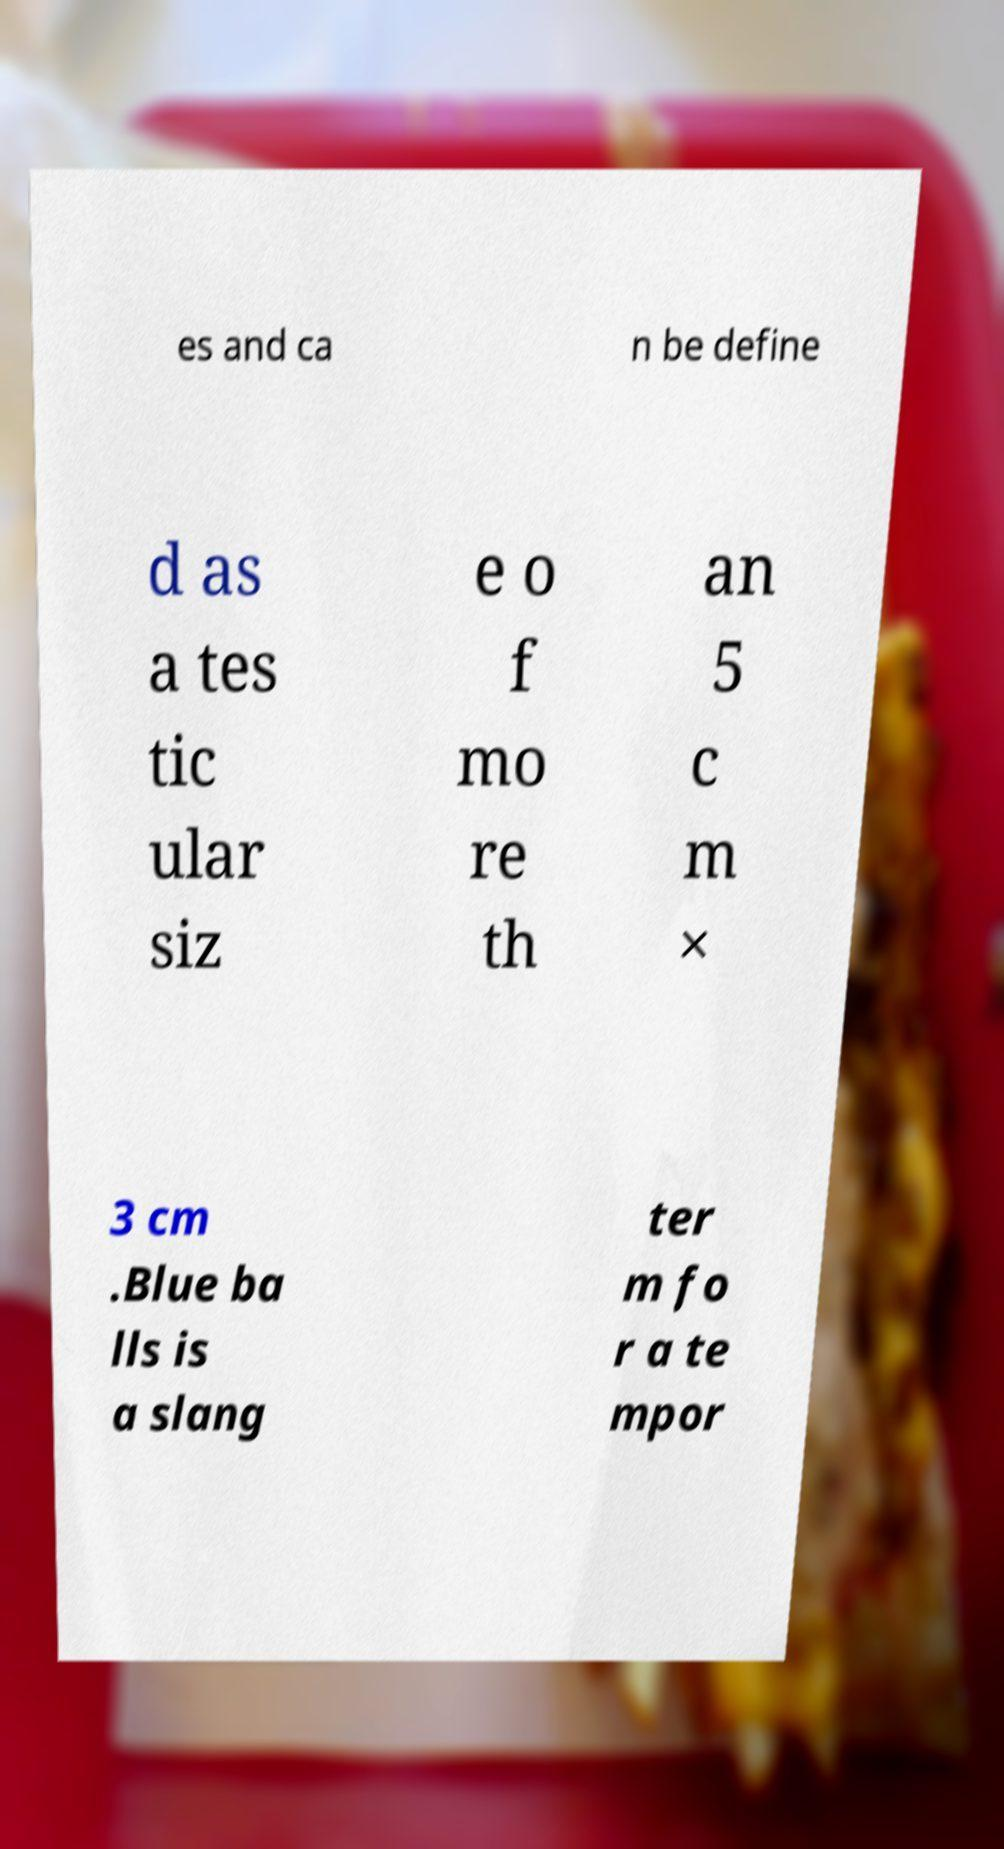Please read and relay the text visible in this image. What does it say? es and ca n be define d as a tes tic ular siz e o f mo re th an 5 c m × 3 cm .Blue ba lls is a slang ter m fo r a te mpor 